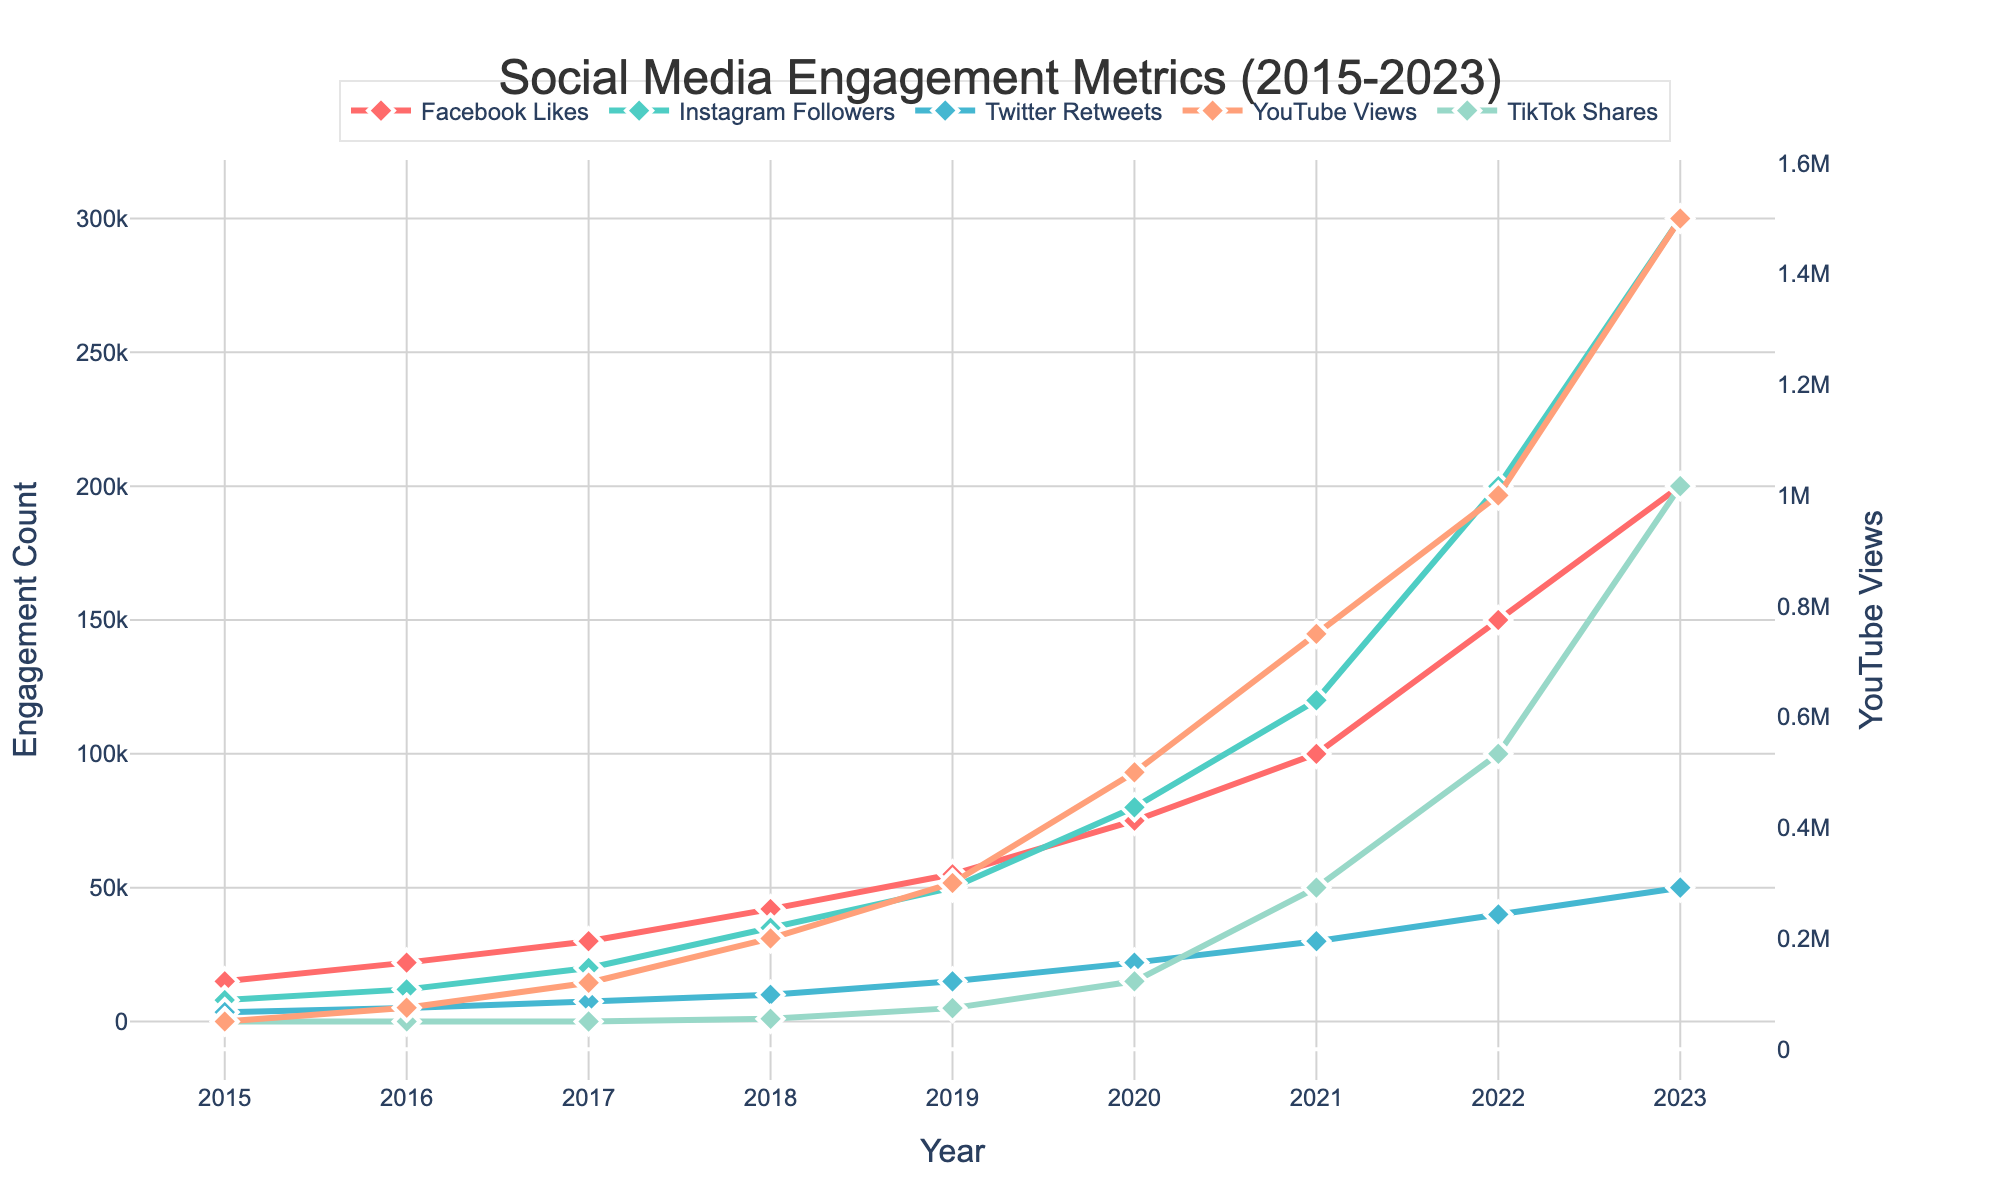What's the trend of Instagram followers from 2015 to 2023? Instagram followers show a consistent upward trend from 2015 to 2023, increasing from 8,000 in 2015 to 300,000 in 2023.
Answer: Consistent upward trend Which platform had the highest engagement in 2023? YouTube had the highest engagement in 2023 with 1,500,000 views.
Answer: YouTube How did Twitter retweets compare to TikTok shares in 2020? In 2020, Twitter retweets were at 22,000, whereas TikTok shares were at 15,000, making Twitter retweets higher.
Answer: Twitter retweets were higher What is the total number of Facebook Likes and Instagram Followers combined in 2021? Facebook Likes in 2021 were 100,000 and Instagram Followers were 120,000. Combined, they sum up to 220,000.
Answer: 220,000 What year did TikTok Shares first appear, and how much did they reach that year? TikTok Shares first appeared in 2018, reaching 1,000 shares.
Answer: 2018 with 1,000 shares Is there a year where the number of Twitter Retweets and Instagram Followers were equal? None of the years have equal numbers of Twitter Retweets and Instagram Followers.
Answer: No Which years did Facebook Likes double, and what were the values? Facebook Likes doubled in the following years: from 15,000 in 2015 to 30,000 in 2017; 30,000 in 2017 to 60,000 in 2018; and 50,000 in 2019 to 100,000 in 2021.
Answer: 2015 to 2017 and 2017 to 2018, and 2019 to 2021 Compare the growth rates of YouTube Views and TikTok Shares from 2018 to 2023. YouTube Views increased from 200,000 in 2018 to 1,500,000 in 2023, which is 7.5 times growth. TikTok Shares increased from 1,000 in 2018 to 200,000 in 2023, which is 200 times growth.
Answer: TikTok Shares grew faster What's the difference between the number of Facebook Likes and Instagram Followers in 2020? In 2020, Facebook Likes were 75,000 and Instagram Followers were 80,000, leading to a difference of 5,000 followers.
Answer: 5,000 followers 